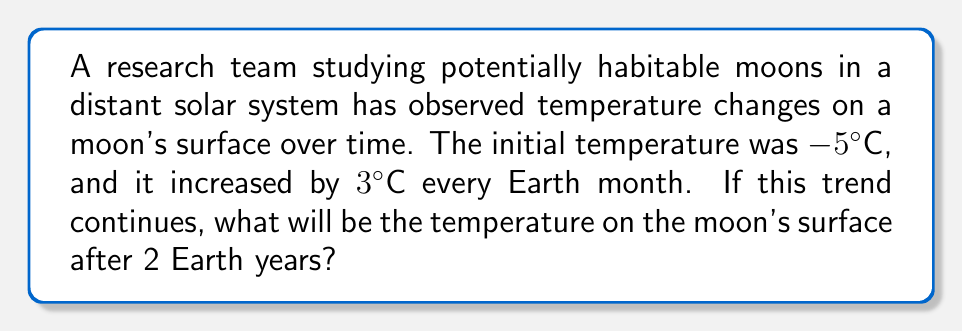What is the answer to this math problem? Let's approach this step-by-step using the concept of arithmetic progression:

1) First, let's identify the components of the arithmetic progression:
   - Initial term (a₁) = -5°C
   - Common difference (d) = 3°C per month

2) We need to find the temperature after 2 Earth years. Let's convert this to months:
   2 years × 12 months/year = 24 months

3) In an arithmetic progression, the nth term is given by the formula:
   $a_n = a_1 + (n - 1)d$

   Where:
   $a_n$ is the nth term
   $a_1$ is the first term
   $n$ is the number of terms
   $d$ is the common difference

4) In our case:
   $a_1 = -5$
   $n = 24 + 1 = 25$ (we add 1 because the initial temperature is the first term)
   $d = 3$

5) Let's substitute these values into the formula:
   $a_{25} = -5 + (25 - 1)3$
   $a_{25} = -5 + (24)3$
   $a_{25} = -5 + 72$
   $a_{25} = 67$

Therefore, after 2 Earth years (24 months), the temperature on the moon's surface will be 67°C.
Answer: 67°C 